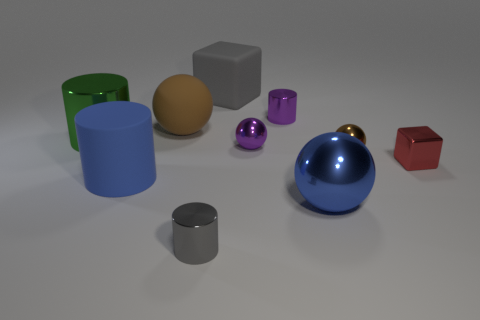Subtract all metal balls. How many balls are left? 1 Subtract all green cylinders. How many cylinders are left? 3 Subtract all red spheres. Subtract all gray cylinders. How many spheres are left? 4 Subtract all blocks. How many objects are left? 8 Subtract 1 purple balls. How many objects are left? 9 Subtract all gray things. Subtract all purple shiny objects. How many objects are left? 6 Add 7 blue rubber objects. How many blue rubber objects are left? 8 Add 8 tiny green metal spheres. How many tiny green metal spheres exist? 8 